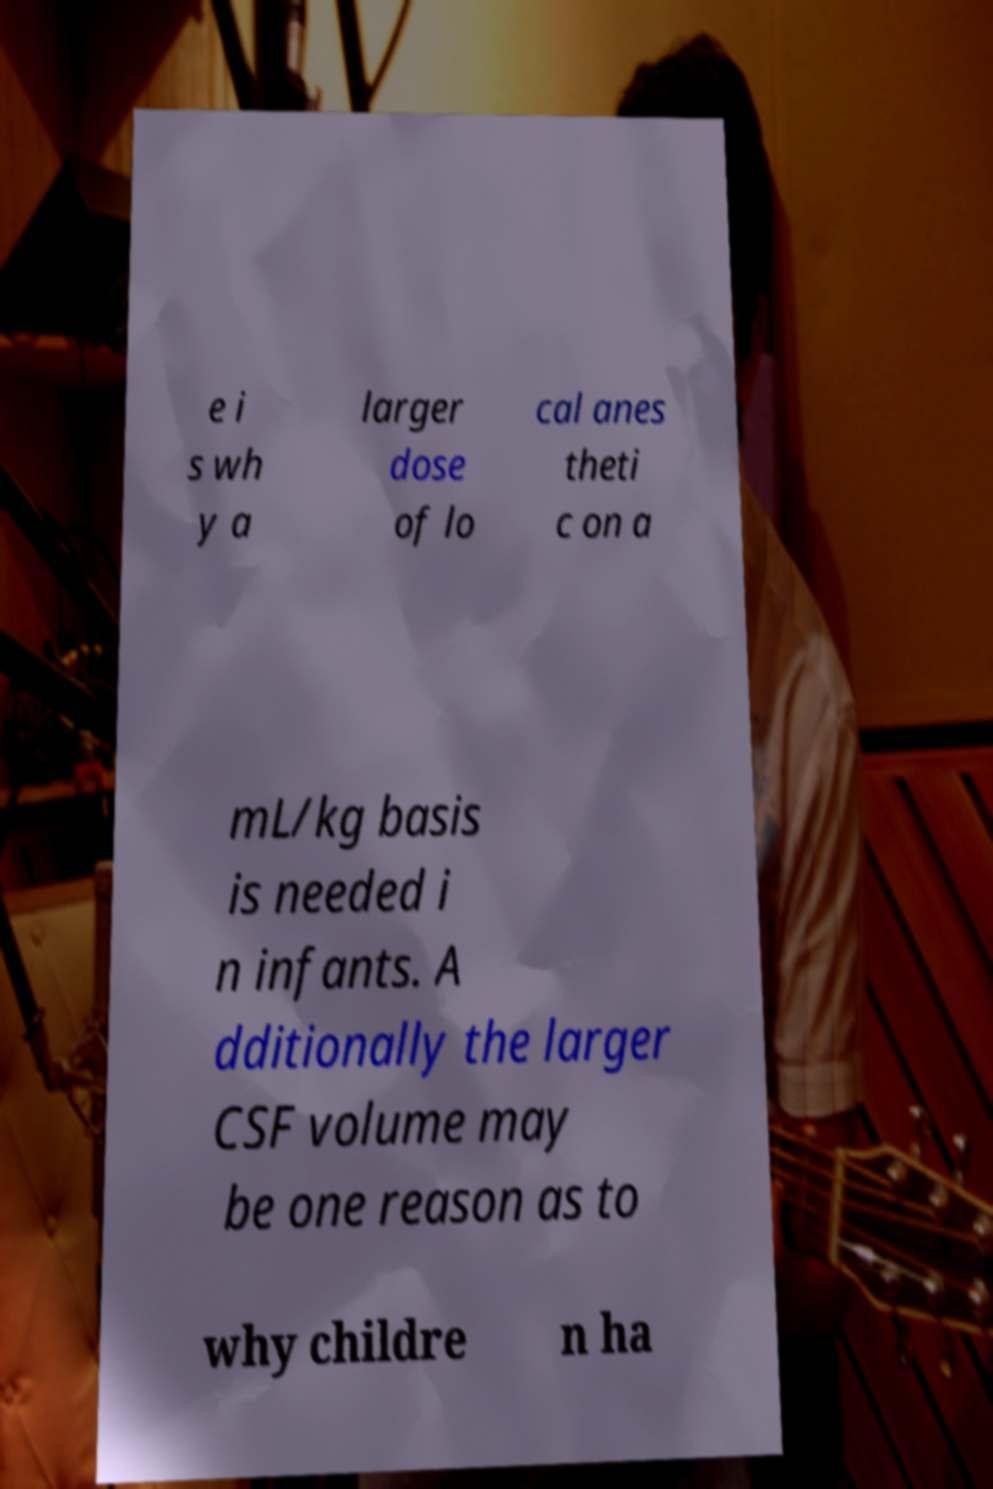For documentation purposes, I need the text within this image transcribed. Could you provide that? e i s wh y a larger dose of lo cal anes theti c on a mL/kg basis is needed i n infants. A dditionally the larger CSF volume may be one reason as to why childre n ha 